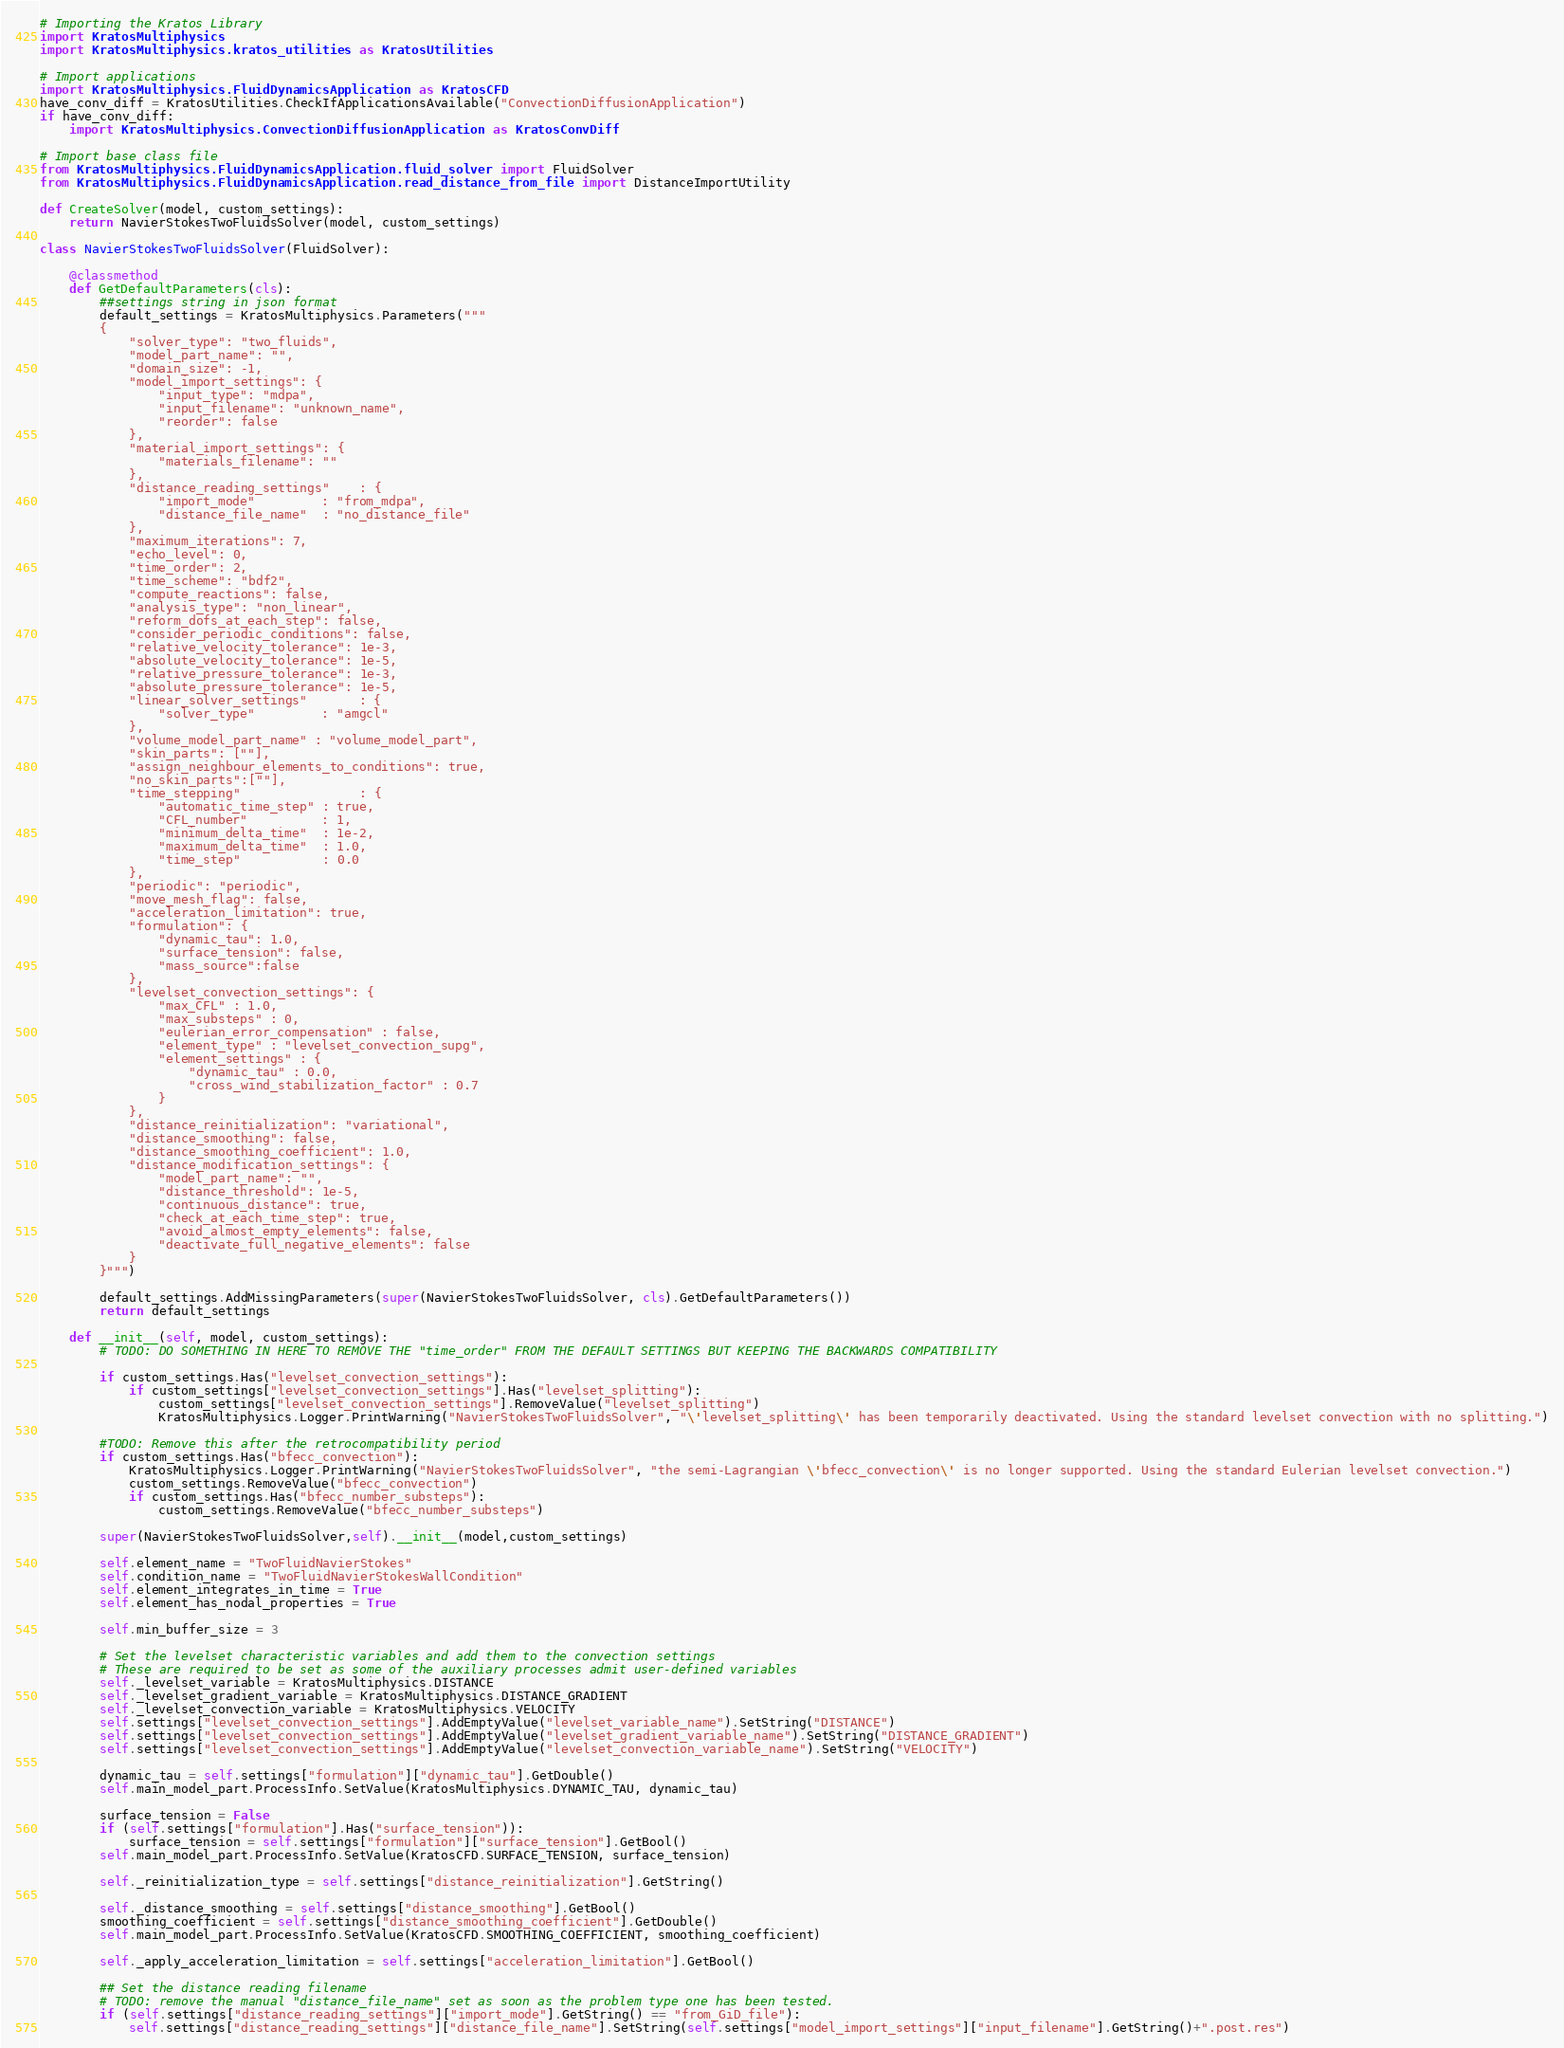Convert code to text. <code><loc_0><loc_0><loc_500><loc_500><_Python_># Importing the Kratos Library
import KratosMultiphysics
import KratosMultiphysics.kratos_utilities as KratosUtilities

# Import applications
import KratosMultiphysics.FluidDynamicsApplication as KratosCFD
have_conv_diff = KratosUtilities.CheckIfApplicationsAvailable("ConvectionDiffusionApplication")
if have_conv_diff:
    import KratosMultiphysics.ConvectionDiffusionApplication as KratosConvDiff

# Import base class file
from KratosMultiphysics.FluidDynamicsApplication.fluid_solver import FluidSolver
from KratosMultiphysics.FluidDynamicsApplication.read_distance_from_file import DistanceImportUtility

def CreateSolver(model, custom_settings):
    return NavierStokesTwoFluidsSolver(model, custom_settings)

class NavierStokesTwoFluidsSolver(FluidSolver):

    @classmethod
    def GetDefaultParameters(cls):
        ##settings string in json format
        default_settings = KratosMultiphysics.Parameters("""
        {
            "solver_type": "two_fluids",
            "model_part_name": "",
            "domain_size": -1,
            "model_import_settings": {
                "input_type": "mdpa",
                "input_filename": "unknown_name",
                "reorder": false
            },
            "material_import_settings": {
                "materials_filename": ""
            },
            "distance_reading_settings"    : {
                "import_mode"         : "from_mdpa",
                "distance_file_name"  : "no_distance_file"
            },
            "maximum_iterations": 7,
            "echo_level": 0,
            "time_order": 2,
            "time_scheme": "bdf2",
            "compute_reactions": false,
            "analysis_type": "non_linear",
            "reform_dofs_at_each_step": false,
            "consider_periodic_conditions": false,
            "relative_velocity_tolerance": 1e-3,
            "absolute_velocity_tolerance": 1e-5,
            "relative_pressure_tolerance": 1e-3,
            "absolute_pressure_tolerance": 1e-5,
            "linear_solver_settings"       : {
                "solver_type"         : "amgcl"
            },
            "volume_model_part_name" : "volume_model_part",
            "skin_parts": [""],
            "assign_neighbour_elements_to_conditions": true,
            "no_skin_parts":[""],
            "time_stepping"                : {
                "automatic_time_step" : true,
                "CFL_number"          : 1,
                "minimum_delta_time"  : 1e-2,
                "maximum_delta_time"  : 1.0,
                "time_step"           : 0.0
            },
            "periodic": "periodic",
            "move_mesh_flag": false,
            "acceleration_limitation": true,
            "formulation": {
                "dynamic_tau": 1.0,
                "surface_tension": false,
                "mass_source":false
            },
            "levelset_convection_settings": {
                "max_CFL" : 1.0,
                "max_substeps" : 0,
                "eulerian_error_compensation" : false,
                "element_type" : "levelset_convection_supg",
                "element_settings" : {
                    "dynamic_tau" : 0.0,
                    "cross_wind_stabilization_factor" : 0.7
                }
            },
            "distance_reinitialization": "variational",
            "distance_smoothing": false,
            "distance_smoothing_coefficient": 1.0,
            "distance_modification_settings": {
                "model_part_name": "",
                "distance_threshold": 1e-5,
                "continuous_distance": true,
                "check_at_each_time_step": true,
                "avoid_almost_empty_elements": false,
                "deactivate_full_negative_elements": false
            }
        }""")

        default_settings.AddMissingParameters(super(NavierStokesTwoFluidsSolver, cls).GetDefaultParameters())
        return default_settings

    def __init__(self, model, custom_settings):
        # TODO: DO SOMETHING IN HERE TO REMOVE THE "time_order" FROM THE DEFAULT SETTINGS BUT KEEPING THE BACKWARDS COMPATIBILITY

        if custom_settings.Has("levelset_convection_settings"):
            if custom_settings["levelset_convection_settings"].Has("levelset_splitting"):
                custom_settings["levelset_convection_settings"].RemoveValue("levelset_splitting")
                KratosMultiphysics.Logger.PrintWarning("NavierStokesTwoFluidsSolver", "\'levelset_splitting\' has been temporarily deactivated. Using the standard levelset convection with no splitting.")

        #TODO: Remove this after the retrocompatibility period
        if custom_settings.Has("bfecc_convection"):
            KratosMultiphysics.Logger.PrintWarning("NavierStokesTwoFluidsSolver", "the semi-Lagrangian \'bfecc_convection\' is no longer supported. Using the standard Eulerian levelset convection.")
            custom_settings.RemoveValue("bfecc_convection")
            if custom_settings.Has("bfecc_number_substeps"):
                custom_settings.RemoveValue("bfecc_number_substeps")

        super(NavierStokesTwoFluidsSolver,self).__init__(model,custom_settings)

        self.element_name = "TwoFluidNavierStokes"
        self.condition_name = "TwoFluidNavierStokesWallCondition"
        self.element_integrates_in_time = True
        self.element_has_nodal_properties = True

        self.min_buffer_size = 3

        # Set the levelset characteristic variables and add them to the convection settings
        # These are required to be set as some of the auxiliary processes admit user-defined variables
        self._levelset_variable = KratosMultiphysics.DISTANCE
        self._levelset_gradient_variable = KratosMultiphysics.DISTANCE_GRADIENT
        self._levelset_convection_variable = KratosMultiphysics.VELOCITY
        self.settings["levelset_convection_settings"].AddEmptyValue("levelset_variable_name").SetString("DISTANCE")
        self.settings["levelset_convection_settings"].AddEmptyValue("levelset_gradient_variable_name").SetString("DISTANCE_GRADIENT")
        self.settings["levelset_convection_settings"].AddEmptyValue("levelset_convection_variable_name").SetString("VELOCITY")

        dynamic_tau = self.settings["formulation"]["dynamic_tau"].GetDouble()
        self.main_model_part.ProcessInfo.SetValue(KratosMultiphysics.DYNAMIC_TAU, dynamic_tau)

        surface_tension = False
        if (self.settings["formulation"].Has("surface_tension")):
            surface_tension = self.settings["formulation"]["surface_tension"].GetBool()
        self.main_model_part.ProcessInfo.SetValue(KratosCFD.SURFACE_TENSION, surface_tension)

        self._reinitialization_type = self.settings["distance_reinitialization"].GetString()

        self._distance_smoothing = self.settings["distance_smoothing"].GetBool()
        smoothing_coefficient = self.settings["distance_smoothing_coefficient"].GetDouble()
        self.main_model_part.ProcessInfo.SetValue(KratosCFD.SMOOTHING_COEFFICIENT, smoothing_coefficient)

        self._apply_acceleration_limitation = self.settings["acceleration_limitation"].GetBool()

        ## Set the distance reading filename
        # TODO: remove the manual "distance_file_name" set as soon as the problem type one has been tested.
        if (self.settings["distance_reading_settings"]["import_mode"].GetString() == "from_GiD_file"):
            self.settings["distance_reading_settings"]["distance_file_name"].SetString(self.settings["model_import_settings"]["input_filename"].GetString()+".post.res")
</code> 